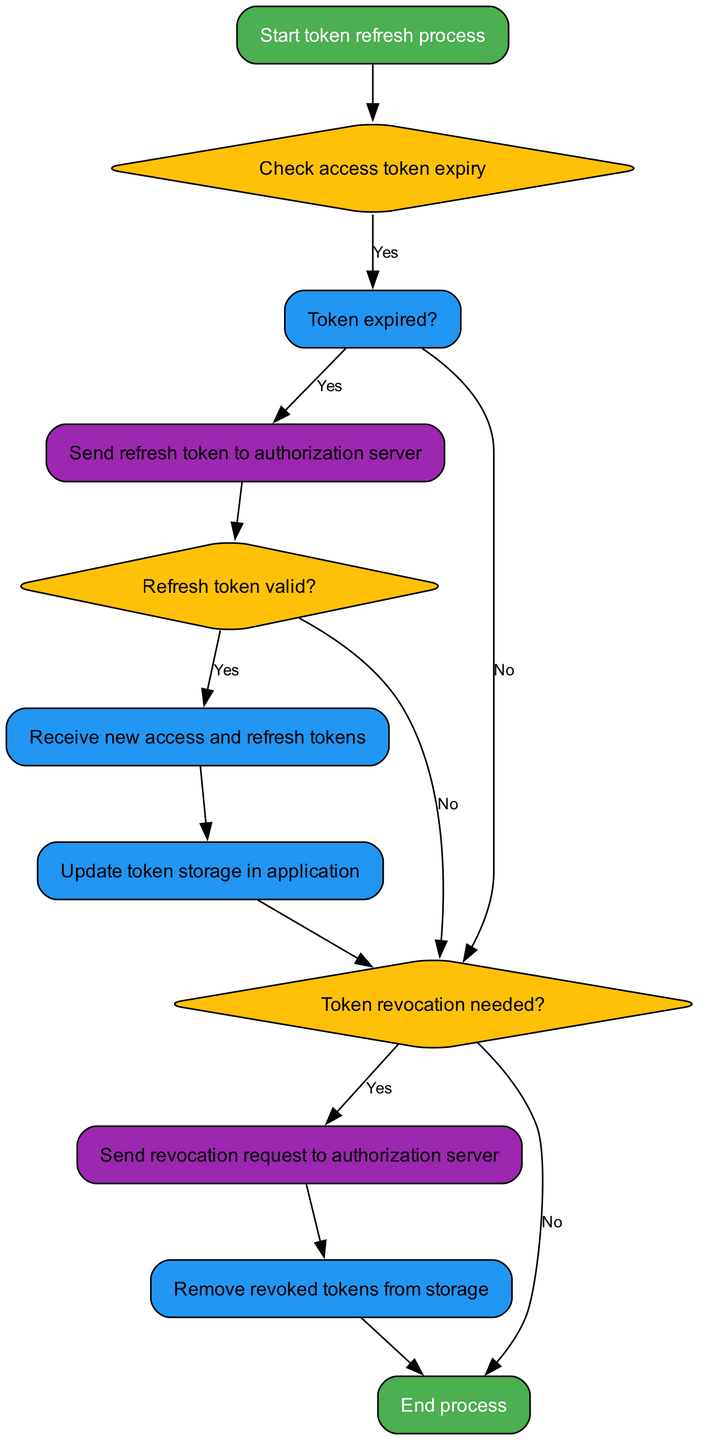What is the first step in the token refresh process? The diagram starts with the node labeled "Start token refresh process," indicating that this is the initial action taken in the procedure.
Answer: Start token refresh process How many nodes are present in the diagram? By counting all the individual nodes listed in the ‘elements’ section of the data, we find there are eleven nodes in total.
Answer: Eleven What is the action taken if the access token is expired? According to the flow, if the access token is expired, the next action is to "Send refresh token to authorization server," indicated by the connection from the expired decision node.
Answer: Send refresh token to authorization server What happens if the refresh token is invalid? If the refresh token is invalid, the process moves to "Token revocation needed?" as indicated by the connection from the valid refresh decision node.
Answer: Token revocation needed? What action is taken after receiving the new tokens? After the new access and refresh tokens are received, the next action is to "Update token storage in application," as shown in the flow following the new tokens node.
Answer: Update token storage in application If revocation is needed, what request is sent next? If token revocation is needed, the next action as depicted in the flow chart is to "Send revocation request to authorization server." This is evidenced by the connection from the revoke check node.
Answer: Send revocation request to authorization server What is the last step in the process? The last step indicated in the diagram is "End process," which marks the conclusion of the token refresh and revocation procedure following the removal of revoked tokens.
Answer: End process If the access token is not expired, what decision is made next? If the access token is not expired, the flow leads to a check for whether token revocation is needed, as shown in the diagram's connection from the expired decision node, which leads to revoke check.
Answer: Token revocation needed? How does the process proceed if the new tokens are successfully received? Upon successful reception of new tokens, the process continues to the action of updating the token storage in the application, which follows the new tokens node in the flow.
Answer: Update token storage in application 